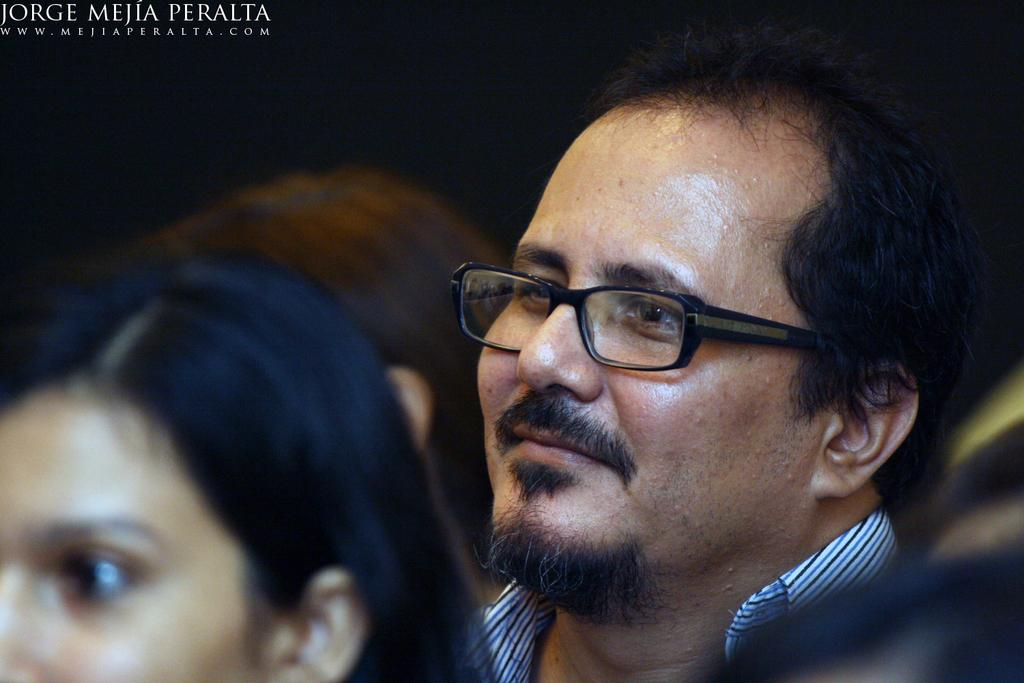Who or what can be seen in the image? There are people in the image. What can be observed about the background of the image? The background of the image is dark. Is there any additional information or marking present in the image? Yes, there is a watermark in the top left corner of the image. How many oranges are being held by the people in the image? There are no oranges visible in the image; the people are not holding any. 